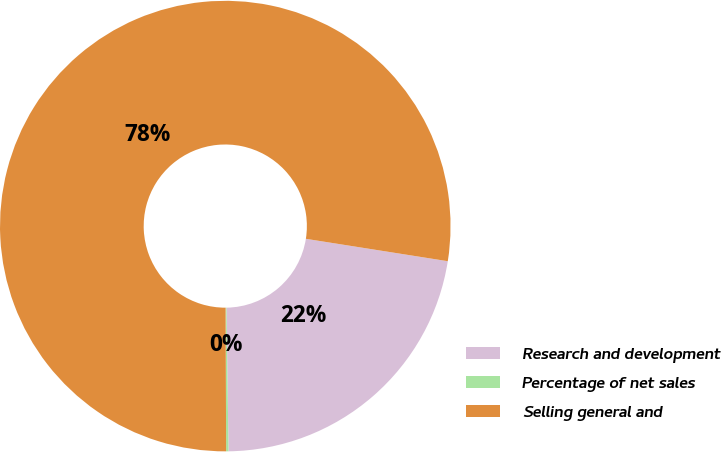Convert chart to OTSL. <chart><loc_0><loc_0><loc_500><loc_500><pie_chart><fcel>Research and development<fcel>Percentage of net sales<fcel>Selling general and<nl><fcel>22.28%<fcel>0.17%<fcel>77.56%<nl></chart> 